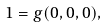<formula> <loc_0><loc_0><loc_500><loc_500>\ 1 = g ( 0 , 0 , 0 ) ,</formula> 